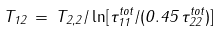Convert formula to latex. <formula><loc_0><loc_0><loc_500><loc_500>T _ { 1 2 } \, = \, T _ { 2 , 2 } / \ln [ \tau _ { 1 1 } ^ { t o t } / ( 0 . 4 5 \, \tau _ { 2 2 } ^ { t o t } ) ]</formula> 